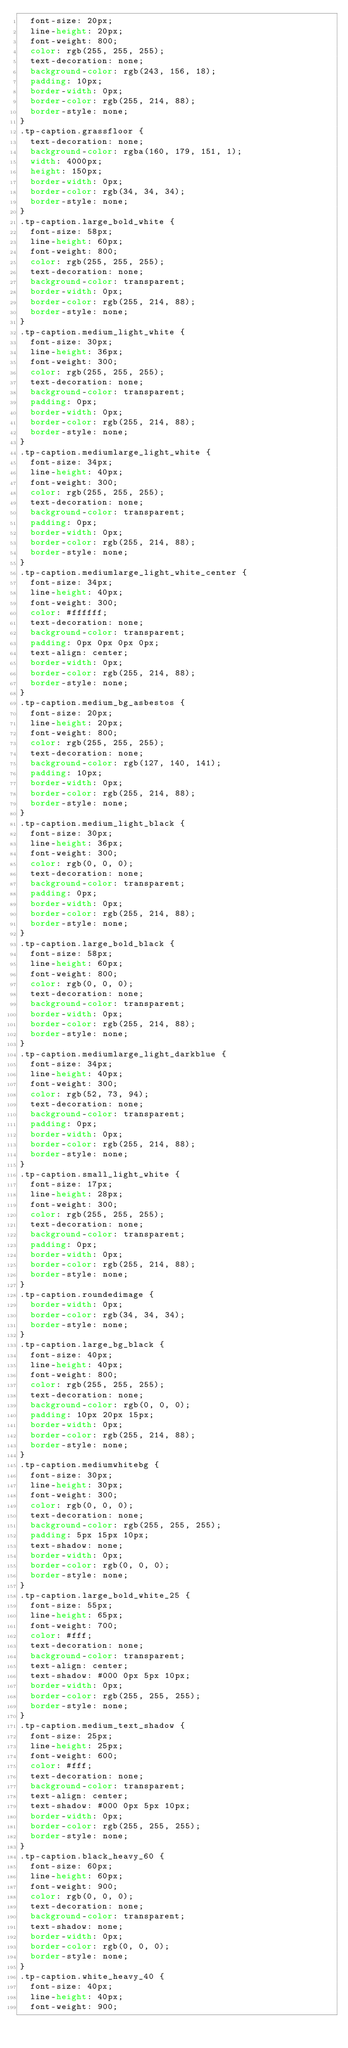<code> <loc_0><loc_0><loc_500><loc_500><_CSS_>	font-size: 20px;
	line-height: 20px;
	font-weight: 800;
	color: rgb(255, 255, 255);
	text-decoration: none;
	background-color: rgb(243, 156, 18);
	padding: 10px;
	border-width: 0px;
	border-color: rgb(255, 214, 88);
	border-style: none;
}
.tp-caption.grassfloor {
	text-decoration: none;
	background-color: rgba(160, 179, 151, 1);
	width: 4000px;
	height: 150px;
	border-width: 0px;
	border-color: rgb(34, 34, 34);
	border-style: none;
}
.tp-caption.large_bold_white {
	font-size: 58px;
	line-height: 60px;
	font-weight: 800;
	color: rgb(255, 255, 255);
	text-decoration: none;
	background-color: transparent;
	border-width: 0px;
	border-color: rgb(255, 214, 88);
	border-style: none;
}
.tp-caption.medium_light_white {
	font-size: 30px;
	line-height: 36px;
	font-weight: 300;
	color: rgb(255, 255, 255);
	text-decoration: none;
	background-color: transparent;
	padding: 0px;
	border-width: 0px;
	border-color: rgb(255, 214, 88);
	border-style: none;
}
.tp-caption.mediumlarge_light_white {
	font-size: 34px;
	line-height: 40px;
	font-weight: 300;
	color: rgb(255, 255, 255);
	text-decoration: none;
	background-color: transparent;
	padding: 0px;
	border-width: 0px;
	border-color: rgb(255, 214, 88);
	border-style: none;
}
.tp-caption.mediumlarge_light_white_center {
	font-size: 34px;
	line-height: 40px;
	font-weight: 300;
	color: #ffffff;
	text-decoration: none;
	background-color: transparent;
	padding: 0px 0px 0px 0px;
	text-align: center;
	border-width: 0px;
	border-color: rgb(255, 214, 88);
	border-style: none;
}
.tp-caption.medium_bg_asbestos {
	font-size: 20px;
	line-height: 20px;
	font-weight: 800;
	color: rgb(255, 255, 255);
	text-decoration: none;
	background-color: rgb(127, 140, 141);
	padding: 10px;
	border-width: 0px;
	border-color: rgb(255, 214, 88);
	border-style: none;
}
.tp-caption.medium_light_black {
	font-size: 30px;
	line-height: 36px;
	font-weight: 300;
	color: rgb(0, 0, 0);
	text-decoration: none;
	background-color: transparent;
	padding: 0px;
	border-width: 0px;
	border-color: rgb(255, 214, 88);
	border-style: none;
}
.tp-caption.large_bold_black {
	font-size: 58px;
	line-height: 60px;
	font-weight: 800;
	color: rgb(0, 0, 0);
	text-decoration: none;
	background-color: transparent;
	border-width: 0px;
	border-color: rgb(255, 214, 88);
	border-style: none;
}
.tp-caption.mediumlarge_light_darkblue {
	font-size: 34px;
	line-height: 40px;
	font-weight: 300;
	color: rgb(52, 73, 94);
	text-decoration: none;
	background-color: transparent;
	padding: 0px;
	border-width: 0px;
	border-color: rgb(255, 214, 88);
	border-style: none;
}
.tp-caption.small_light_white {
	font-size: 17px;
	line-height: 28px;
	font-weight: 300;
	color: rgb(255, 255, 255);
	text-decoration: none;
	background-color: transparent;
	padding: 0px;
	border-width: 0px;
	border-color: rgb(255, 214, 88);
	border-style: none;
}
.tp-caption.roundedimage {
	border-width: 0px;
	border-color: rgb(34, 34, 34);
	border-style: none;
}
.tp-caption.large_bg_black {
	font-size: 40px;
	line-height: 40px;
	font-weight: 800;
	color: rgb(255, 255, 255);
	text-decoration: none;
	background-color: rgb(0, 0, 0);
	padding: 10px 20px 15px;
	border-width: 0px;
	border-color: rgb(255, 214, 88);
	border-style: none;
}
.tp-caption.mediumwhitebg {
	font-size: 30px;
	line-height: 30px;
	font-weight: 300;
	color: rgb(0, 0, 0);
	text-decoration: none;
	background-color: rgb(255, 255, 255);
	padding: 5px 15px 10px;
	text-shadow: none;
	border-width: 0px;
	border-color: rgb(0, 0, 0);
	border-style: none;
}
.tp-caption.large_bold_white_25 {
	font-size: 55px;
	line-height: 65px;
	font-weight: 700;
	color: #fff;
	text-decoration: none;
	background-color: transparent;
	text-align: center;
	text-shadow: #000 0px 5px 10px;
	border-width: 0px;
	border-color: rgb(255, 255, 255);
	border-style: none;
}
.tp-caption.medium_text_shadow {
	font-size: 25px;
	line-height: 25px;
	font-weight: 600;
	color: #fff;
	text-decoration: none;
	background-color: transparent;
	text-align: center;
	text-shadow: #000 0px 5px 10px;
	border-width: 0px;
	border-color: rgb(255, 255, 255);
	border-style: none;
}
.tp-caption.black_heavy_60 {
	font-size: 60px;
	line-height: 60px;
	font-weight: 900;
	color: rgb(0, 0, 0);
	text-decoration: none;
	background-color: transparent;
	text-shadow: none;
	border-width: 0px;
	border-color: rgb(0, 0, 0);
	border-style: none;
}
.tp-caption.white_heavy_40 {
	font-size: 40px;
	line-height: 40px;
	font-weight: 900;</code> 